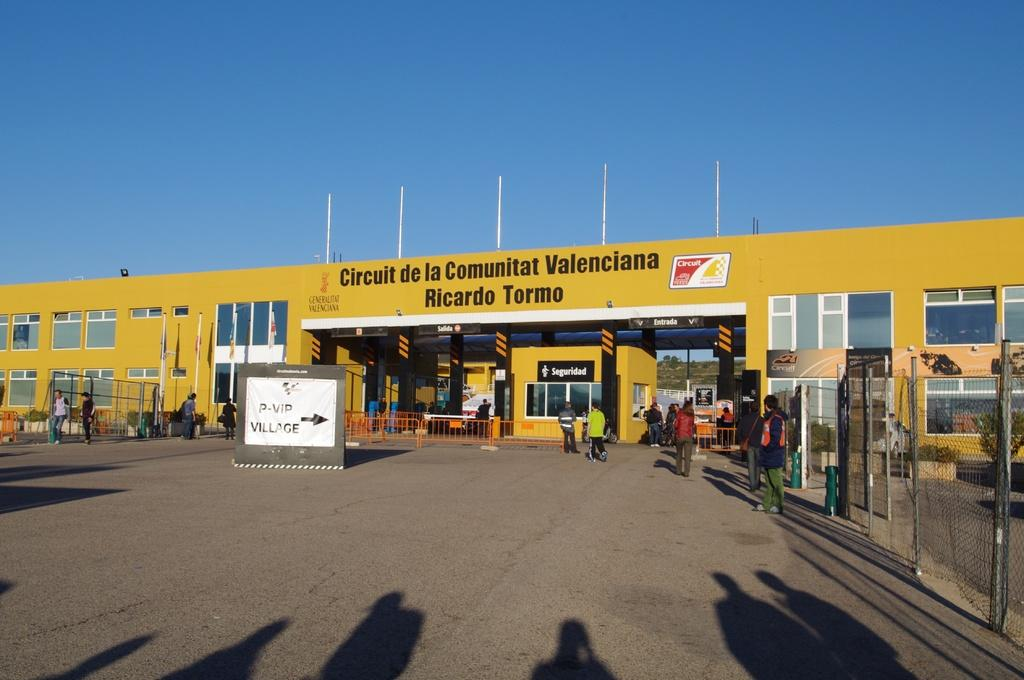Provide a one-sentence caption for the provided image. A yellow building with the words Circuit de la Communitat Valenciana on it. 